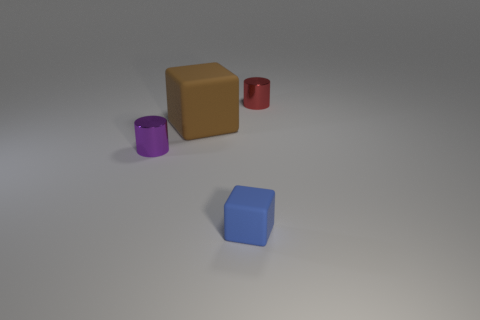Is the material of the tiny blue block to the right of the small purple object the same as the red cylinder?
Keep it short and to the point. No. There is another object that is the same shape as the small blue object; what size is it?
Provide a succinct answer. Large. What is the material of the tiny object that is both to the right of the purple thing and in front of the red cylinder?
Your answer should be very brief. Rubber. There is a brown thing; are there any tiny rubber blocks behind it?
Your answer should be compact. No. Is the purple object made of the same material as the red cylinder?
Keep it short and to the point. Yes. There is a red cylinder that is the same size as the purple object; what material is it?
Your answer should be compact. Metal. How many things are either metallic cylinders in front of the tiny red cylinder or big purple shiny things?
Make the answer very short. 1. Are there an equal number of small blue rubber blocks in front of the brown thing and purple cylinders?
Provide a short and direct response. Yes. What color is the thing that is both on the left side of the blue rubber object and in front of the large matte block?
Ensure brevity in your answer.  Purple. What number of cubes are either tiny green shiny things or red objects?
Make the answer very short. 0. 